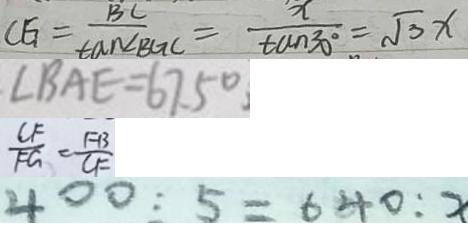<formula> <loc_0><loc_0><loc_500><loc_500>C E _ { 1 } = \frac { B C } { \tan \angle B G C } = \frac { x } { \tan 3 0 ^ { \circ } } = \sqrt { 3 } x 
 、 \angle B A E = 6 7 . 5 ^ { \circ } 、 
 \frac { C F } { F G } = \frac { F B } { C F } 
 4 0 0 : 5 = 6 4 0 : x</formula> 